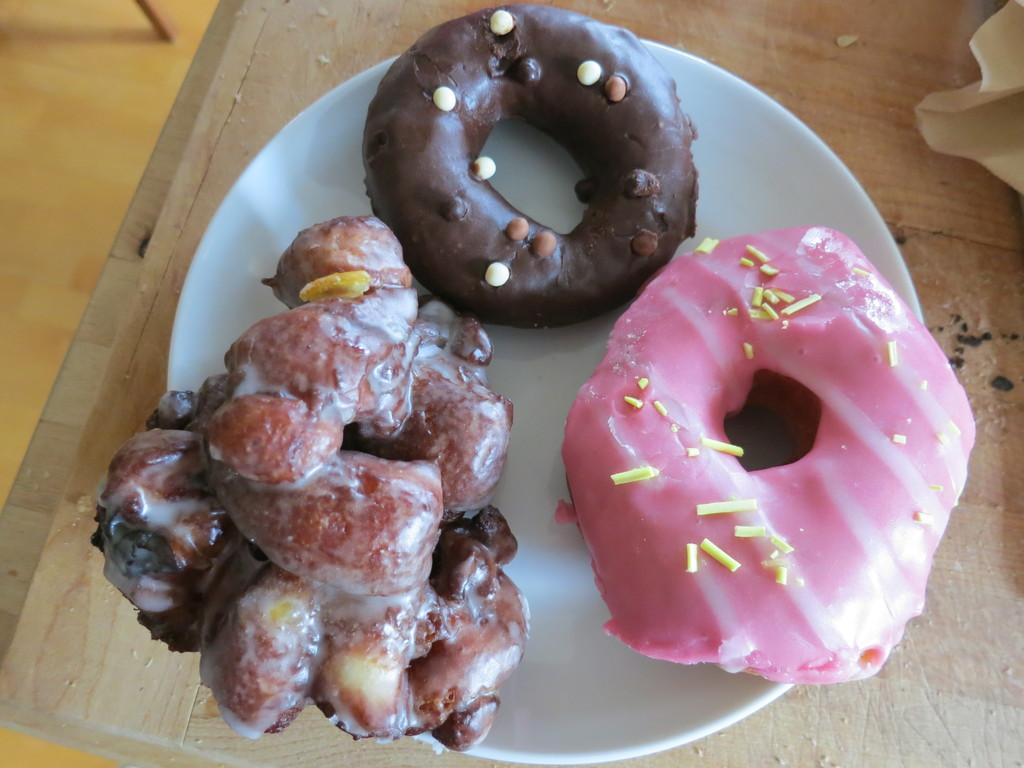What is located in the center of the image? There is a plate in the middle of the image. Where is the plate placed? The plate is on a table. What can be found on the plate? There is food in the plate. What type of cars can be seen driving by in the morning in the image? There are no cars or references to time of day in the image; it only features a plate with food on a table. 